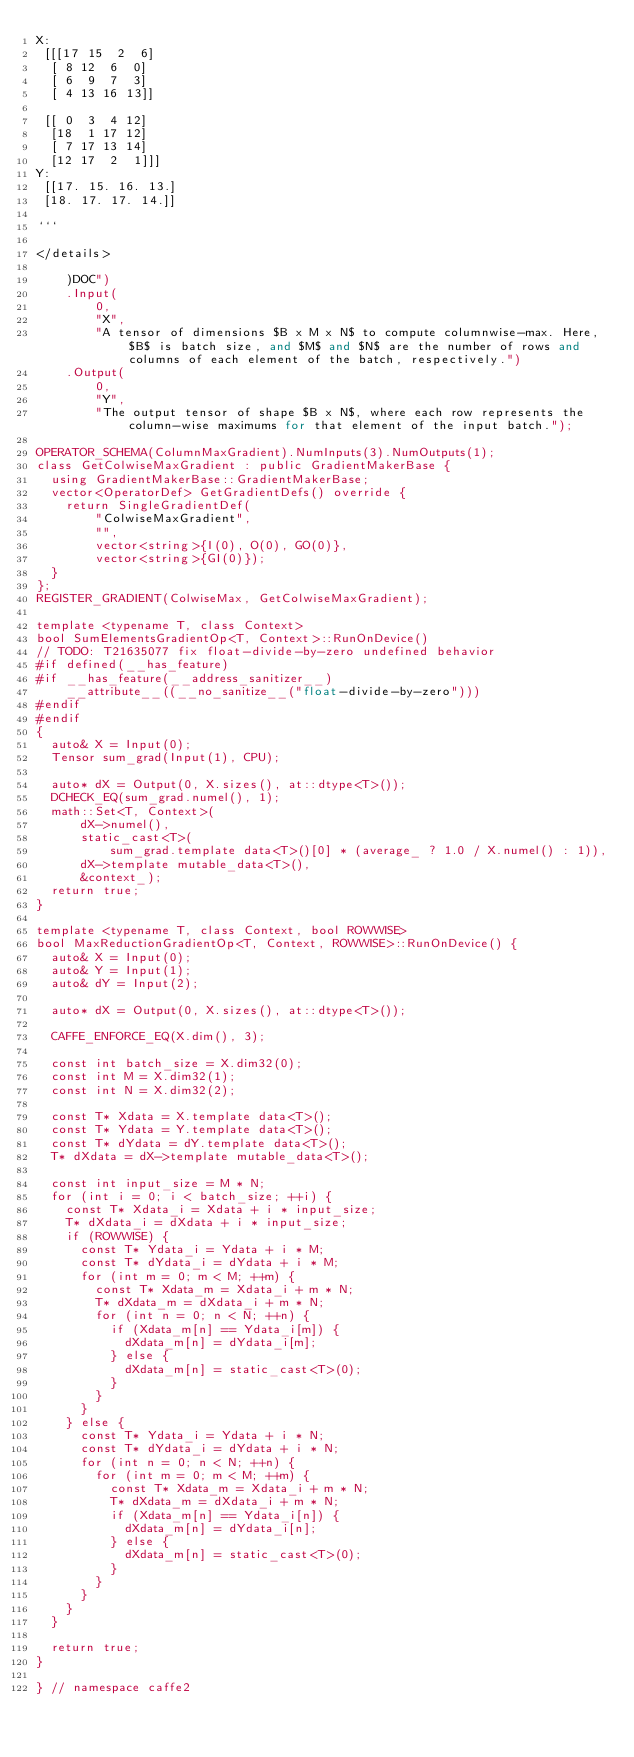Convert code to text. <code><loc_0><loc_0><loc_500><loc_500><_C++_>X:
 [[[17 15  2  6]
  [ 8 12  6  0]
  [ 6  9  7  3]
  [ 4 13 16 13]]

 [[ 0  3  4 12]
  [18  1 17 12]
  [ 7 17 13 14]
  [12 17  2  1]]]
Y:
 [[17. 15. 16. 13.]
 [18. 17. 17. 14.]]

```

</details>

    )DOC")
    .Input(
        0,
        "X",
        "A tensor of dimensions $B x M x N$ to compute columnwise-max. Here, $B$ is batch size, and $M$ and $N$ are the number of rows and columns of each element of the batch, respectively.")
    .Output(
        0,
        "Y",
        "The output tensor of shape $B x N$, where each row represents the column-wise maximums for that element of the input batch.");

OPERATOR_SCHEMA(ColumnMaxGradient).NumInputs(3).NumOutputs(1);
class GetColwiseMaxGradient : public GradientMakerBase {
  using GradientMakerBase::GradientMakerBase;
  vector<OperatorDef> GetGradientDefs() override {
    return SingleGradientDef(
        "ColwiseMaxGradient",
        "",
        vector<string>{I(0), O(0), GO(0)},
        vector<string>{GI(0)});
  }
};
REGISTER_GRADIENT(ColwiseMax, GetColwiseMaxGradient);

template <typename T, class Context>
bool SumElementsGradientOp<T, Context>::RunOnDevice()
// TODO: T21635077 fix float-divide-by-zero undefined behavior
#if defined(__has_feature)
#if __has_feature(__address_sanitizer__)
    __attribute__((__no_sanitize__("float-divide-by-zero")))
#endif
#endif
{
  auto& X = Input(0);
  Tensor sum_grad(Input(1), CPU);

  auto* dX = Output(0, X.sizes(), at::dtype<T>());
  DCHECK_EQ(sum_grad.numel(), 1);
  math::Set<T, Context>(
      dX->numel(),
      static_cast<T>(
          sum_grad.template data<T>()[0] * (average_ ? 1.0 / X.numel() : 1)),
      dX->template mutable_data<T>(),
      &context_);
  return true;
}

template <typename T, class Context, bool ROWWISE>
bool MaxReductionGradientOp<T, Context, ROWWISE>::RunOnDevice() {
  auto& X = Input(0);
  auto& Y = Input(1);
  auto& dY = Input(2);

  auto* dX = Output(0, X.sizes(), at::dtype<T>());

  CAFFE_ENFORCE_EQ(X.dim(), 3);

  const int batch_size = X.dim32(0);
  const int M = X.dim32(1);
  const int N = X.dim32(2);

  const T* Xdata = X.template data<T>();
  const T* Ydata = Y.template data<T>();
  const T* dYdata = dY.template data<T>();
  T* dXdata = dX->template mutable_data<T>();

  const int input_size = M * N;
  for (int i = 0; i < batch_size; ++i) {
    const T* Xdata_i = Xdata + i * input_size;
    T* dXdata_i = dXdata + i * input_size;
    if (ROWWISE) {
      const T* Ydata_i = Ydata + i * M;
      const T* dYdata_i = dYdata + i * M;
      for (int m = 0; m < M; ++m) {
        const T* Xdata_m = Xdata_i + m * N;
        T* dXdata_m = dXdata_i + m * N;
        for (int n = 0; n < N; ++n) {
          if (Xdata_m[n] == Ydata_i[m]) {
            dXdata_m[n] = dYdata_i[m];
          } else {
            dXdata_m[n] = static_cast<T>(0);
          }
        }
      }
    } else {
      const T* Ydata_i = Ydata + i * N;
      const T* dYdata_i = dYdata + i * N;
      for (int n = 0; n < N; ++n) {
        for (int m = 0; m < M; ++m) {
          const T* Xdata_m = Xdata_i + m * N;
          T* dXdata_m = dXdata_i + m * N;
          if (Xdata_m[n] == Ydata_i[n]) {
            dXdata_m[n] = dYdata_i[n];
          } else {
            dXdata_m[n] = static_cast<T>(0);
          }
        }
      }
    }
  }

  return true;
}

} // namespace caffe2
</code> 